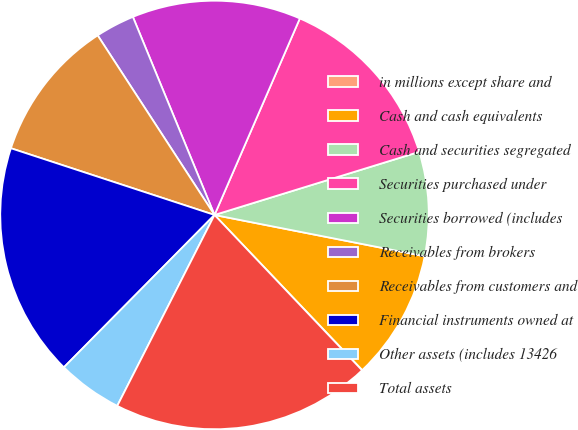Convert chart to OTSL. <chart><loc_0><loc_0><loc_500><loc_500><pie_chart><fcel>in millions except share and<fcel>Cash and cash equivalents<fcel>Cash and securities segregated<fcel>Securities purchased under<fcel>Securities borrowed (includes<fcel>Receivables from brokers<fcel>Receivables from customers and<fcel>Financial instruments owned at<fcel>Other assets (includes 13426<fcel>Total assets<nl><fcel>0.02%<fcel>9.8%<fcel>7.85%<fcel>13.72%<fcel>12.74%<fcel>2.96%<fcel>10.78%<fcel>17.63%<fcel>4.91%<fcel>19.59%<nl></chart> 